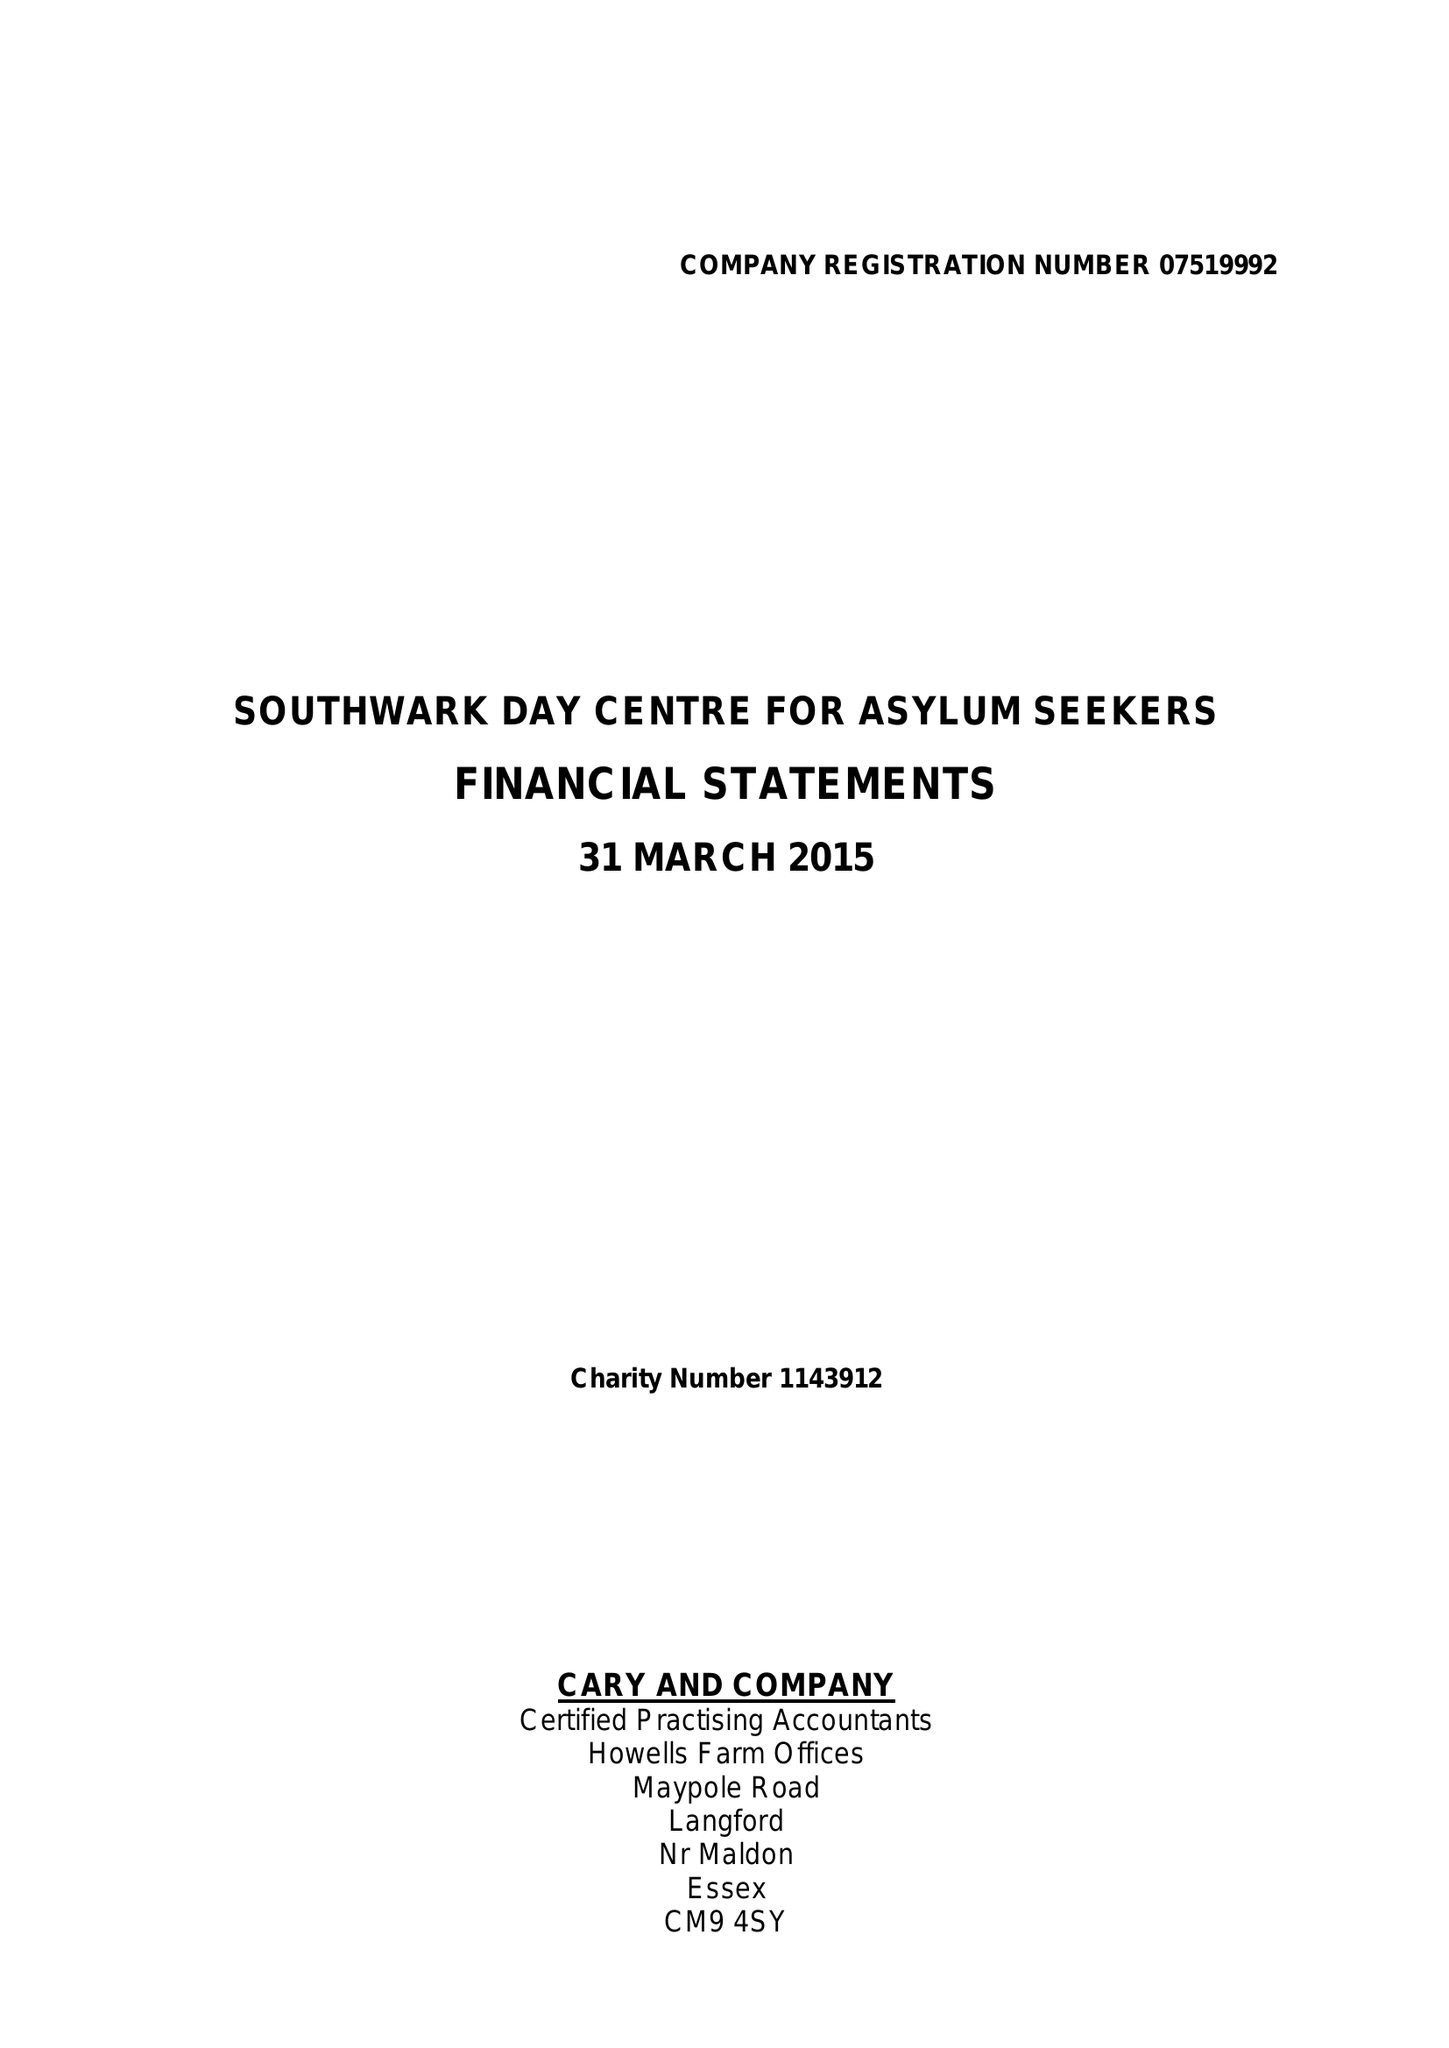What is the value for the address__post_town?
Answer the question using a single word or phrase. None 